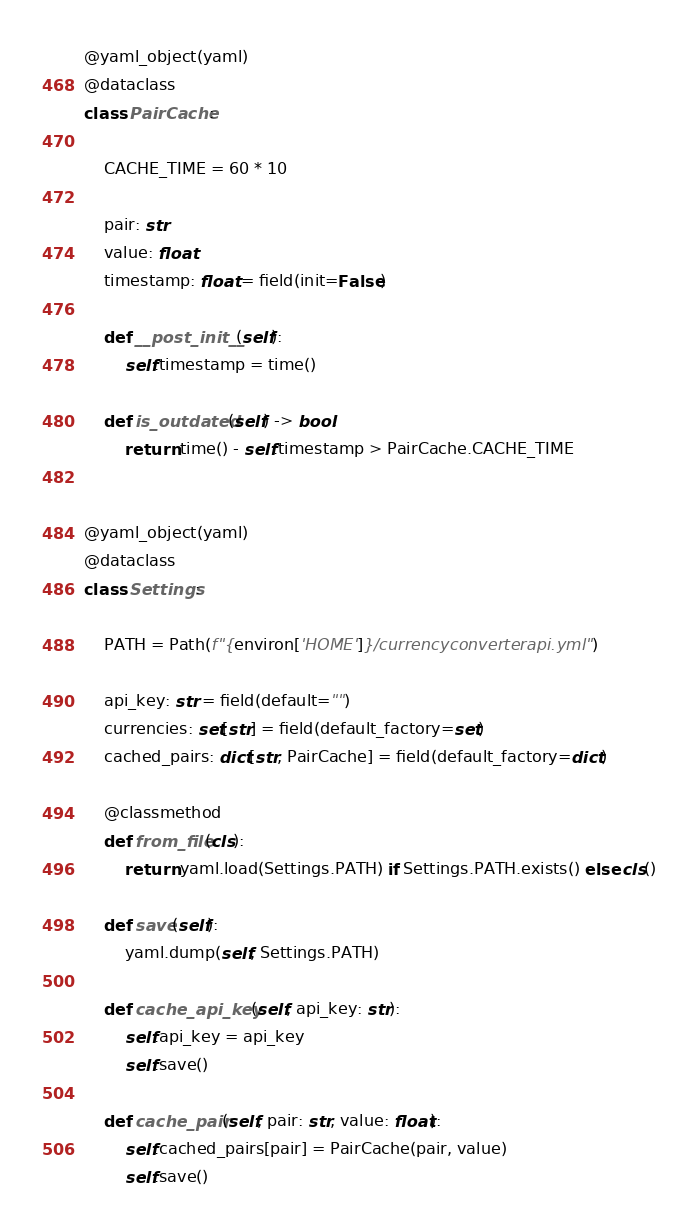<code> <loc_0><loc_0><loc_500><loc_500><_Python_>@yaml_object(yaml)
@dataclass
class PairCache:

    CACHE_TIME = 60 * 10

    pair: str
    value: float
    timestamp: float = field(init=False)

    def __post_init__(self):
        self.timestamp = time()

    def is_outdated(self) -> bool:
        return time() - self.timestamp > PairCache.CACHE_TIME


@yaml_object(yaml)
@dataclass
class Settings:

    PATH = Path(f"{environ['HOME']}/currencyconverterapi.yml")

    api_key: str = field(default="")
    currencies: set[str] = field(default_factory=set)
    cached_pairs: dict[str, PairCache] = field(default_factory=dict)

    @classmethod
    def from_file(cls):
        return yaml.load(Settings.PATH) if Settings.PATH.exists() else cls()

    def save(self):
        yaml.dump(self, Settings.PATH)

    def cache_api_key(self, api_key: str):
        self.api_key = api_key
        self.save()

    def cache_pair(self, pair: str, value: float):
        self.cached_pairs[pair] = PairCache(pair, value)
        self.save()
</code> 